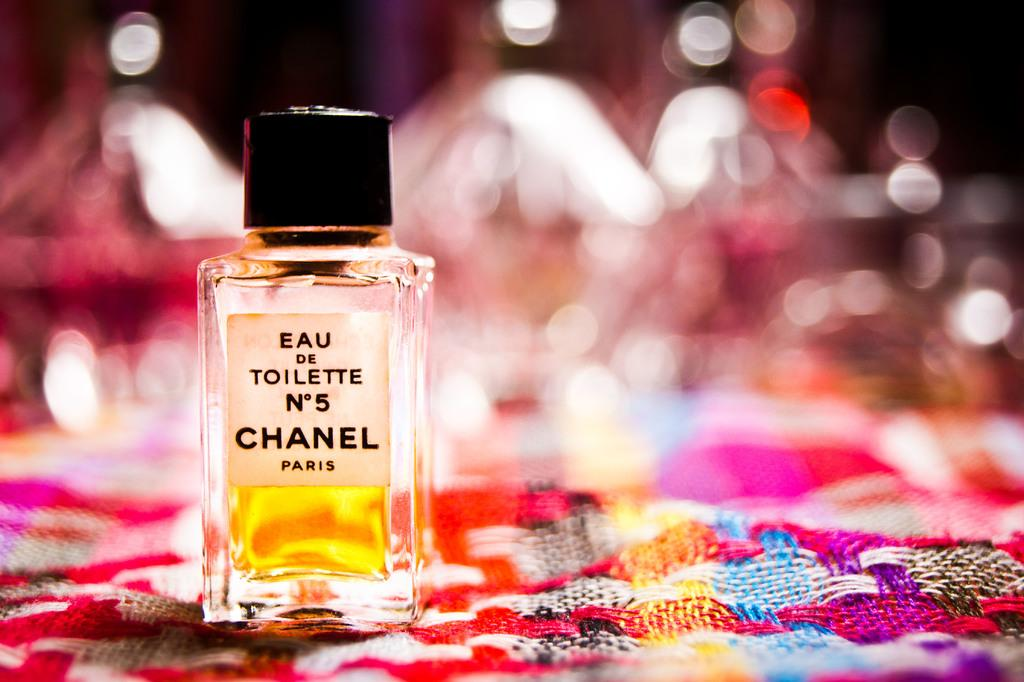<image>
Offer a succinct explanation of the picture presented. A bottle of EAU on Toilette Number 5 Chanel Paris. 